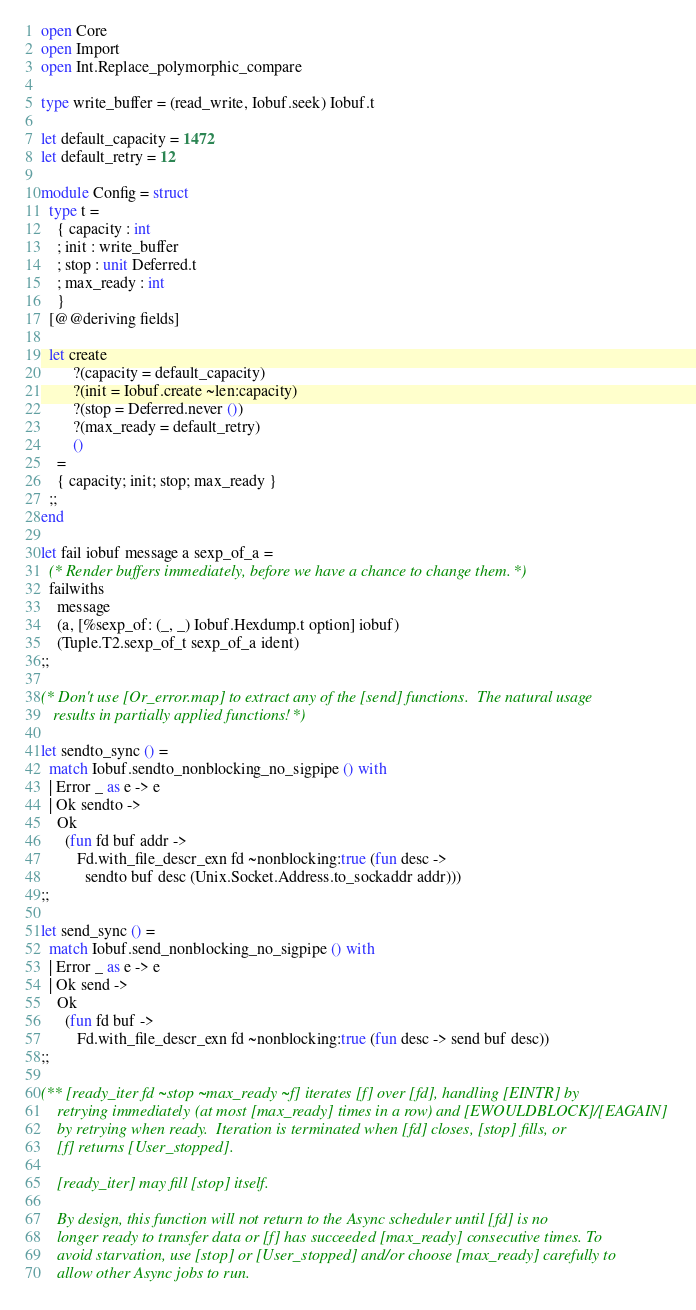<code> <loc_0><loc_0><loc_500><loc_500><_OCaml_>open Core
open Import
open Int.Replace_polymorphic_compare

type write_buffer = (read_write, Iobuf.seek) Iobuf.t

let default_capacity = 1472
let default_retry = 12

module Config = struct
  type t =
    { capacity : int
    ; init : write_buffer
    ; stop : unit Deferred.t
    ; max_ready : int
    }
  [@@deriving fields]

  let create
        ?(capacity = default_capacity)
        ?(init = Iobuf.create ~len:capacity)
        ?(stop = Deferred.never ())
        ?(max_ready = default_retry)
        ()
    =
    { capacity; init; stop; max_ready }
  ;;
end

let fail iobuf message a sexp_of_a =
  (* Render buffers immediately, before we have a chance to change them. *)
  failwiths
    message
    (a, [%sexp_of: (_, _) Iobuf.Hexdump.t option] iobuf)
    (Tuple.T2.sexp_of_t sexp_of_a ident)
;;

(* Don't use [Or_error.map] to extract any of the [send] functions.  The natural usage
   results in partially applied functions! *)

let sendto_sync () =
  match Iobuf.sendto_nonblocking_no_sigpipe () with
  | Error _ as e -> e
  | Ok sendto ->
    Ok
      (fun fd buf addr ->
         Fd.with_file_descr_exn fd ~nonblocking:true (fun desc ->
           sendto buf desc (Unix.Socket.Address.to_sockaddr addr)))
;;

let send_sync () =
  match Iobuf.send_nonblocking_no_sigpipe () with
  | Error _ as e -> e
  | Ok send ->
    Ok
      (fun fd buf ->
         Fd.with_file_descr_exn fd ~nonblocking:true (fun desc -> send buf desc))
;;

(** [ready_iter fd ~stop ~max_ready ~f] iterates [f] over [fd], handling [EINTR] by
    retrying immediately (at most [max_ready] times in a row) and [EWOULDBLOCK]/[EAGAIN]
    by retrying when ready.  Iteration is terminated when [fd] closes, [stop] fills, or
    [f] returns [User_stopped].

    [ready_iter] may fill [stop] itself.

    By design, this function will not return to the Async scheduler until [fd] is no
    longer ready to transfer data or [f] has succeeded [max_ready] consecutive times. To
    avoid starvation, use [stop] or [User_stopped] and/or choose [max_ready] carefully to
    allow other Async jobs to run.
</code> 